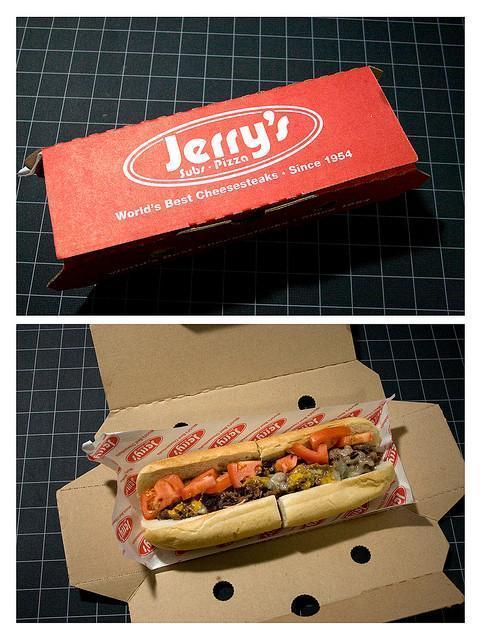How many dining tables are there?
Give a very brief answer. 2. How many of the people are wearing a green top?
Give a very brief answer. 0. 